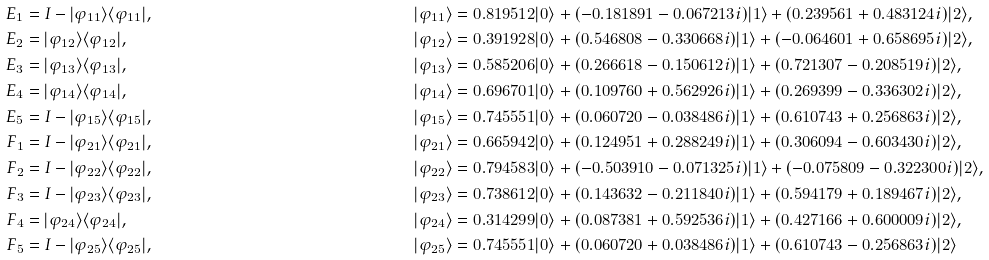<formula> <loc_0><loc_0><loc_500><loc_500>E _ { 1 } & = I - | \varphi _ { 1 1 } \rangle \langle \varphi _ { 1 1 } | , & \quad & | \varphi _ { 1 1 } \rangle = 0 . 8 1 9 5 1 2 | 0 \rangle + ( - 0 . 1 8 1 8 9 1 - 0 . 0 6 7 2 1 3 i ) | 1 \rangle + ( 0 . 2 3 9 5 6 1 + 0 . 4 8 3 1 2 4 i ) | 2 \rangle , \\ E _ { 2 } & = | \varphi _ { 1 2 } \rangle \langle \varphi _ { 1 2 } | , & \quad & | \varphi _ { 1 2 } \rangle = 0 . 3 9 1 9 2 8 | 0 \rangle + ( 0 . 5 4 6 8 0 8 - 0 . 3 3 0 6 6 8 i ) | 1 \rangle + ( - 0 . 0 6 4 6 0 1 + 0 . 6 5 8 6 9 5 i ) | 2 \rangle , \\ E _ { 3 } & = | \varphi _ { 1 3 } \rangle \langle \varphi _ { 1 3 } | , & \quad & | \varphi _ { 1 3 } \rangle = 0 . 5 8 5 2 0 6 | 0 \rangle + ( 0 . 2 6 6 6 1 8 - 0 . 1 5 0 6 1 2 i ) | 1 \rangle + ( 0 . 7 2 1 3 0 7 - 0 . 2 0 8 5 1 9 i ) | 2 \rangle , \\ E _ { 4 } & = | \varphi _ { 1 4 } \rangle \langle \varphi _ { 1 4 } | , & \quad & | \varphi _ { 1 4 } \rangle = 0 . 6 9 6 7 0 1 | 0 \rangle + ( 0 . 1 0 9 7 6 0 + 0 . 5 6 2 9 2 6 i ) | 1 \rangle + ( 0 . 2 6 9 3 9 9 - 0 . 3 3 6 3 0 2 i ) | 2 \rangle , \\ E _ { 5 } & = I - | \varphi _ { 1 5 } \rangle \langle \varphi _ { 1 5 } | , & \quad & | \varphi _ { 1 5 } \rangle = 0 . 7 4 5 5 5 1 | 0 \rangle + ( 0 . 0 6 0 7 2 0 - 0 . 0 3 8 4 8 6 i ) | 1 \rangle + ( 0 . 6 1 0 7 4 3 + 0 . 2 5 6 8 6 3 i ) | 2 \rangle , \\ F _ { 1 } & = I - | \varphi _ { 2 1 } \rangle \langle \varphi _ { 2 1 } | , & \quad & | \varphi _ { 2 1 } \rangle = 0 . 6 6 5 9 4 2 | 0 \rangle + ( 0 . 1 2 4 9 5 1 + 0 . 2 8 8 2 4 9 i ) | 1 \rangle + ( 0 . 3 0 6 0 9 4 - 0 . 6 0 3 4 3 0 i ) | 2 \rangle , \\ F _ { 2 } & = I - | \varphi _ { 2 2 } \rangle \langle \varphi _ { 2 2 } | , & \quad & | \varphi _ { 2 2 } \rangle = 0 . 7 9 4 5 8 3 | 0 \rangle + ( - 0 . 5 0 3 9 1 0 - 0 . 0 7 1 3 2 5 i ) | 1 \rangle + ( - 0 . 0 7 5 8 0 9 - 0 . 3 2 2 3 0 0 i ) | 2 \rangle , \\ F _ { 3 } & = I - | \varphi _ { 2 3 } \rangle \langle \varphi _ { 2 3 } | , & \quad & | \varphi _ { 2 3 } \rangle = 0 . 7 3 8 6 1 2 | 0 \rangle + ( 0 . 1 4 3 6 3 2 - 0 . 2 1 1 8 4 0 i ) | 1 \rangle + ( 0 . 5 9 4 1 7 9 + 0 . 1 8 9 4 6 7 i ) | 2 \rangle , \\ F _ { 4 } & = | \varphi _ { 2 4 } \rangle \langle \varphi _ { 2 4 } | , & \quad & | \varphi _ { 2 4 } \rangle = 0 . 3 1 4 2 9 9 | 0 \rangle + ( 0 . 0 8 7 3 8 1 + 0 . 5 9 2 5 3 6 i ) | 1 \rangle + ( 0 . 4 2 7 1 6 6 + 0 . 6 0 0 0 0 9 i ) | 2 \rangle , \\ F _ { 5 } & = I - | \varphi _ { 2 5 } \rangle \langle \varphi _ { 2 5 } | , & \quad & | \varphi _ { 2 5 } \rangle = 0 . 7 4 5 5 5 1 | 0 \rangle + ( 0 . 0 6 0 7 2 0 + 0 . 0 3 8 4 8 6 i ) | 1 \rangle + ( 0 . 6 1 0 7 4 3 - 0 . 2 5 6 8 6 3 i ) | 2 \rangle</formula> 